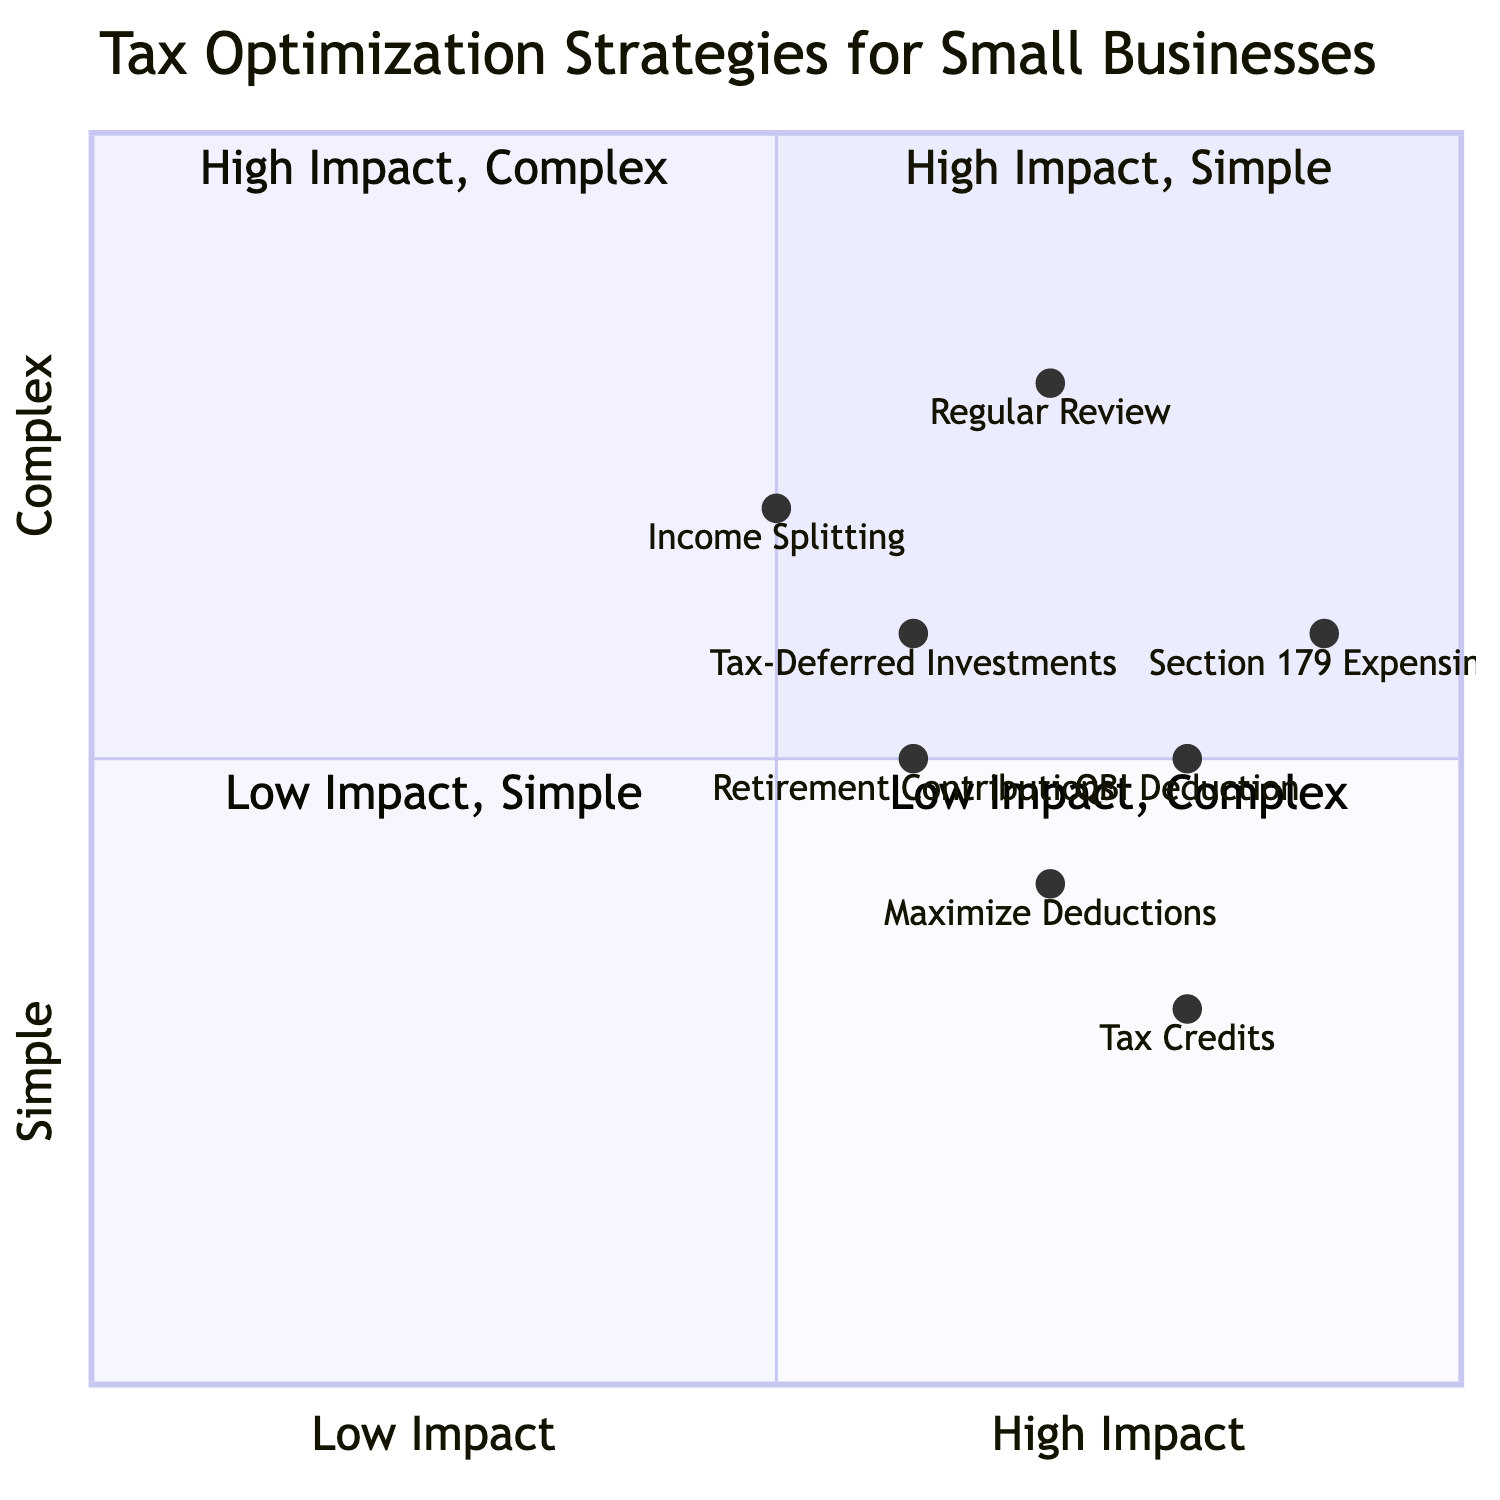What strategy has the highest impact and is simple? The strategy in the quadrant for High Impact and Simple is "Tax Credits," which is located at coordinates corresponding to that criterion.
Answer: Tax Credits Which strategy falls under Low Impact and Complex? Upon inspecting the quadrant for Low Impact and Complex, there are no strategies listed, indicating that this quadrant is empty.
Answer: None How many strategies are listed in the High Impact quadrant? In the High Impact quadrants (both Simple and Complex), there are a total of four strategies: "Tax Credits," "Section 179 Expensing," "QBI Deduction," and "Maximize Deductions."
Answer: 4 What is the complexity level of "Income Splitting"? The complexity level for "Income Splitting" is noted in the diagram as being on the higher end within the quadrant, indicating a complex approach to tax optimization.
Answer: Complex Which strategy is in the same quadrant as "Maximize Deductions"? The "Maximize Deductions" strategy is located in the High Impact, Simple quadrant, and the other strategy in this same quadrant is "Tax Credits."
Answer: Tax Credits What is the relative impact level of "Retirement Contributions"? The impact level of "Retirement Contributions" is higher than Low Impact and is classified as Moderate Impact, but it is positioned below high impact within the diagram.
Answer: Moderate Which strategy has the lowest impact level? The diagram indicates that "Income Splitting" has the lowest position within the Low Impact quadrant and classifies it as Simple.
Answer: Low Impact Which strategy shares the same complexity as "QBI Deduction"? Both "Tax-Deferred Investments" and "QBI Deduction" share the same complexity level noted in the diagram as Moderate, indicated by their similar Y values.
Answer: Tax-Deferred Investments Which two strategies have the same impact level? "Maximize Deductions" and "Retirement Contributions" both share a Moderate impact level, which positions them similarly within the quadrant structure.
Answer: Maximize Deductions, Retirement Contributions 